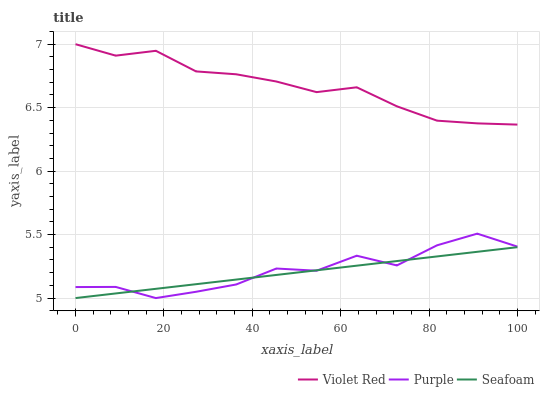Does Seafoam have the minimum area under the curve?
Answer yes or no. Yes. Does Violet Red have the maximum area under the curve?
Answer yes or no. Yes. Does Violet Red have the minimum area under the curve?
Answer yes or no. No. Does Seafoam have the maximum area under the curve?
Answer yes or no. No. Is Seafoam the smoothest?
Answer yes or no. Yes. Is Purple the roughest?
Answer yes or no. Yes. Is Violet Red the smoothest?
Answer yes or no. No. Is Violet Red the roughest?
Answer yes or no. No. Does Purple have the lowest value?
Answer yes or no. Yes. Does Violet Red have the lowest value?
Answer yes or no. No. Does Violet Red have the highest value?
Answer yes or no. Yes. Does Seafoam have the highest value?
Answer yes or no. No. Is Seafoam less than Violet Red?
Answer yes or no. Yes. Is Violet Red greater than Seafoam?
Answer yes or no. Yes. Does Seafoam intersect Purple?
Answer yes or no. Yes. Is Seafoam less than Purple?
Answer yes or no. No. Is Seafoam greater than Purple?
Answer yes or no. No. Does Seafoam intersect Violet Red?
Answer yes or no. No. 